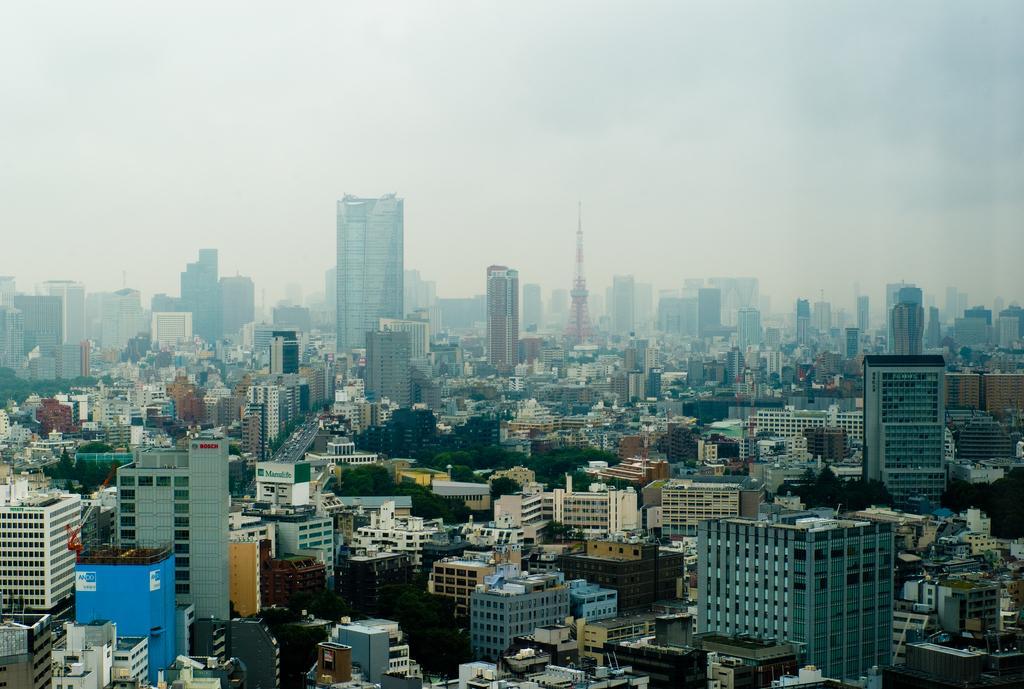In one or two sentences, can you explain what this image depicts? This is an image of a city. In this image there are buildings, vehicles on the road and a sky. 